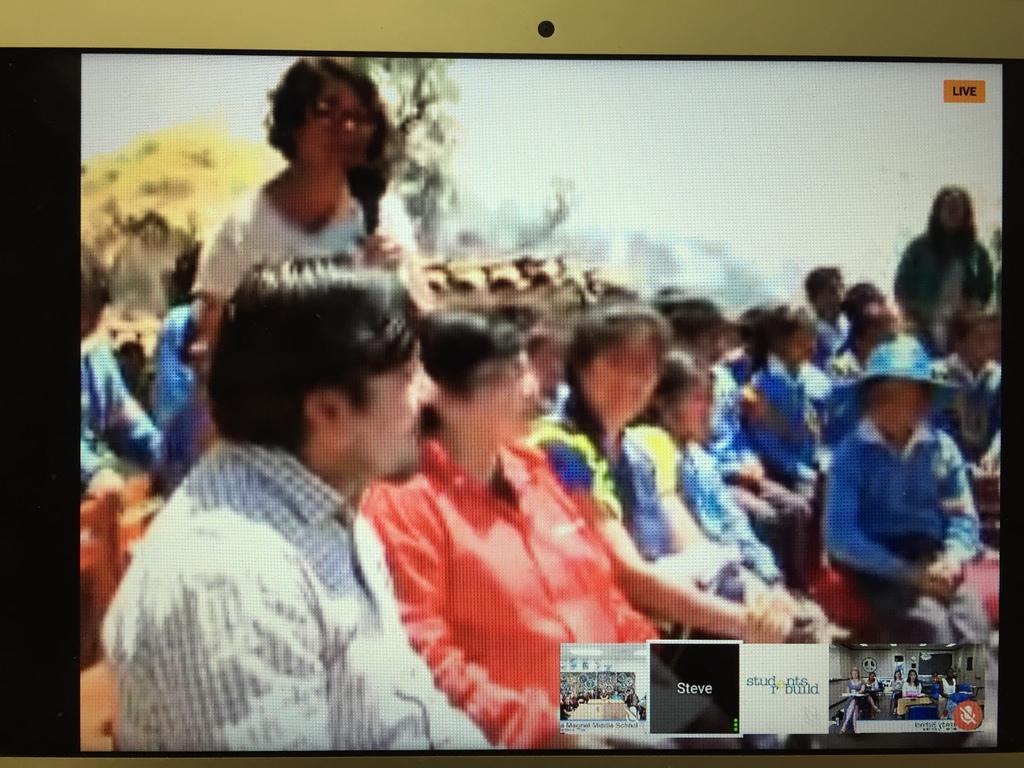Please provide a concise description of this image. In this image I see a screen on which there are number of people who are sitting and I see these 2 persons are standing and this woman is holding a mic in her hand and I see a watermark over here and I see few tabs over here. 